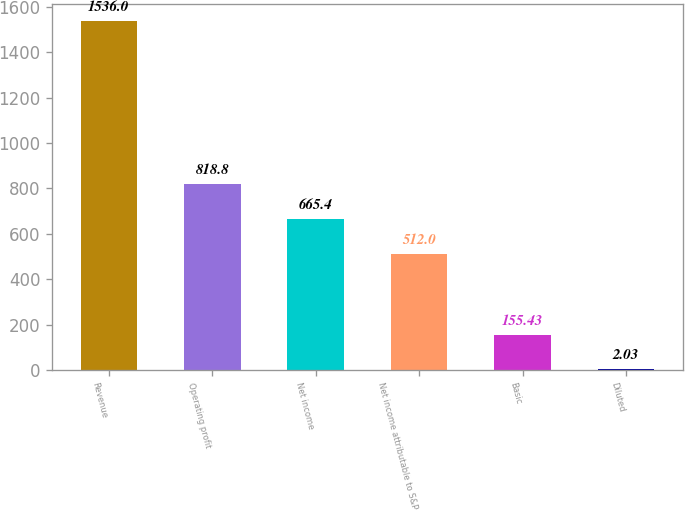Convert chart to OTSL. <chart><loc_0><loc_0><loc_500><loc_500><bar_chart><fcel>Revenue<fcel>Operating profit<fcel>Net income<fcel>Net income attributable to S&P<fcel>Basic<fcel>Diluted<nl><fcel>1536<fcel>818.8<fcel>665.4<fcel>512<fcel>155.43<fcel>2.03<nl></chart> 